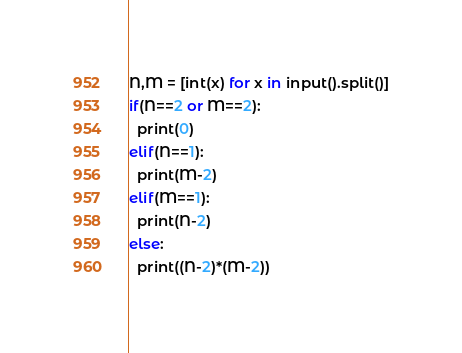<code> <loc_0><loc_0><loc_500><loc_500><_Python_>N,M = [int(x) for x in input().split()]
if(N==2 or M==2):
  print(0)
elif(N==1):
  print(M-2)
elif(M==1):
  print(N-2)
else:
  print((N-2)*(M-2))</code> 